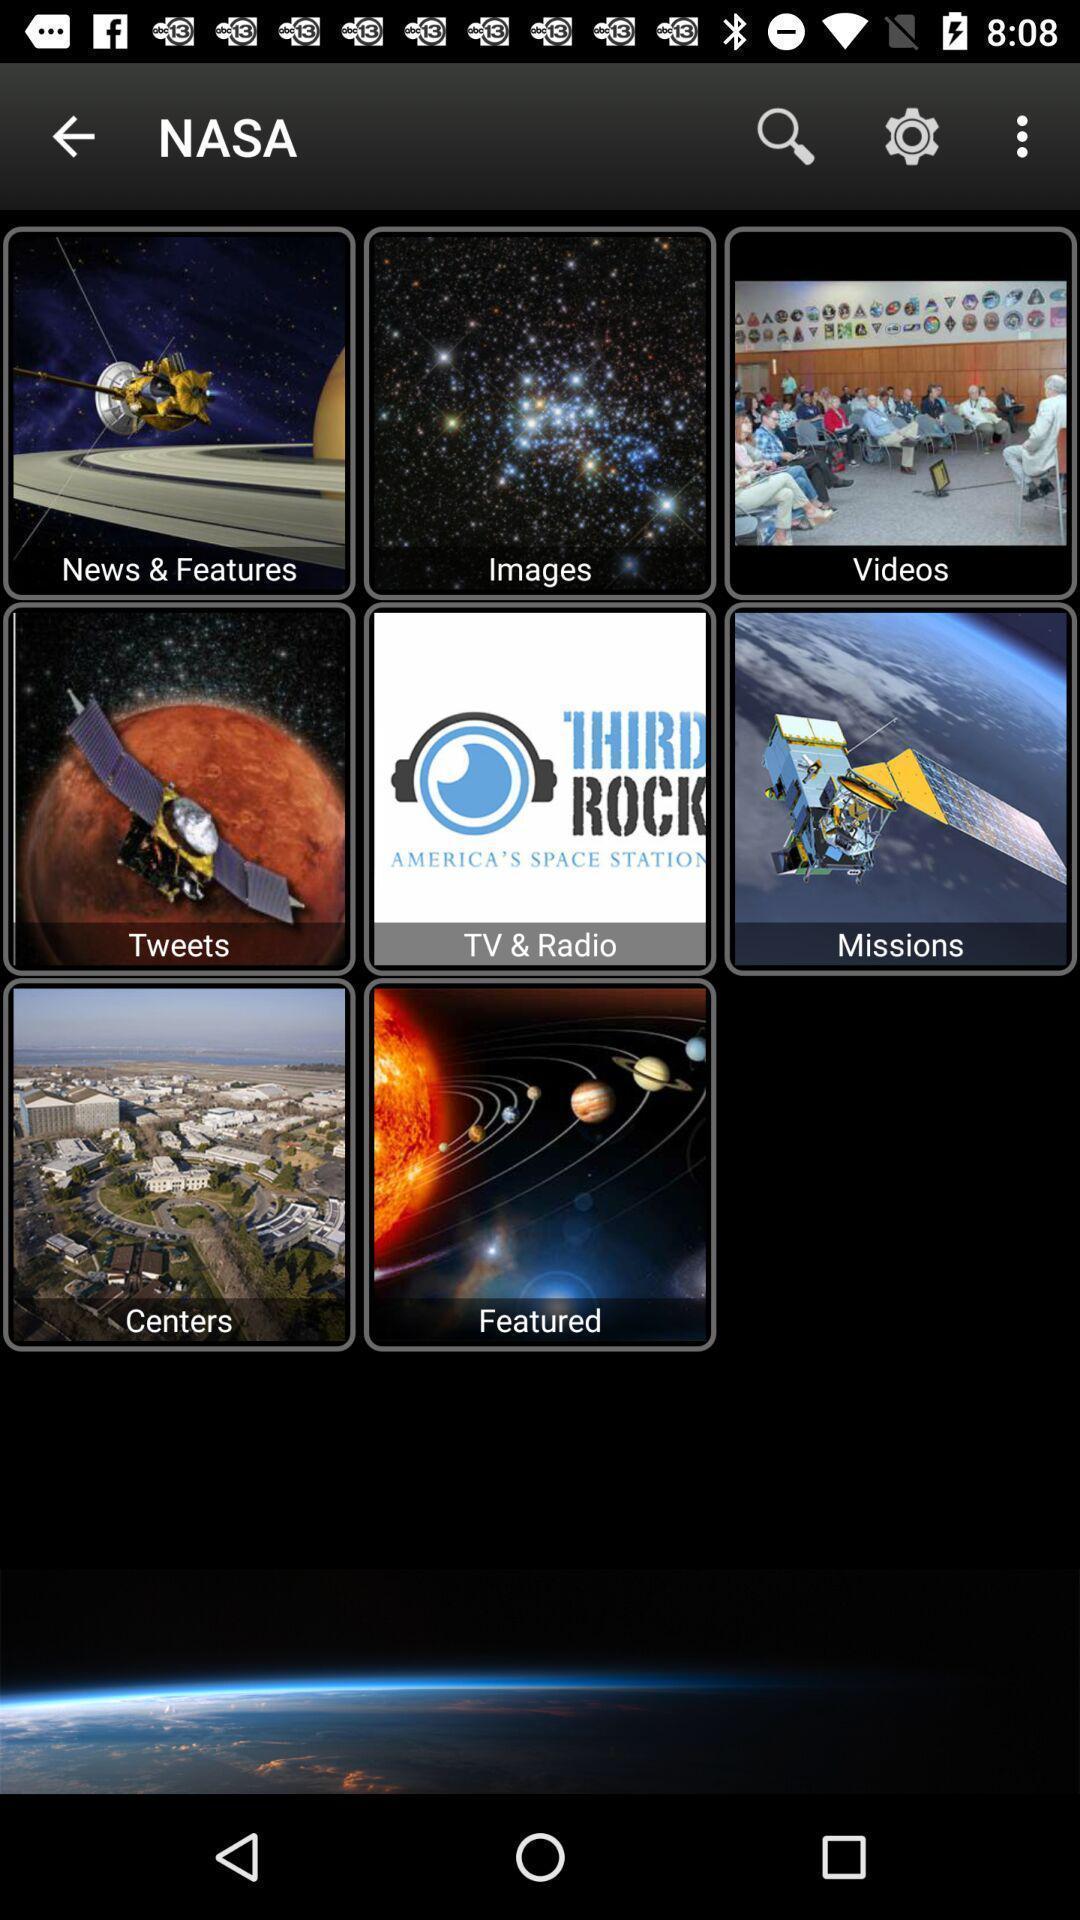Describe this image in words. Screen displaying the different categories. 